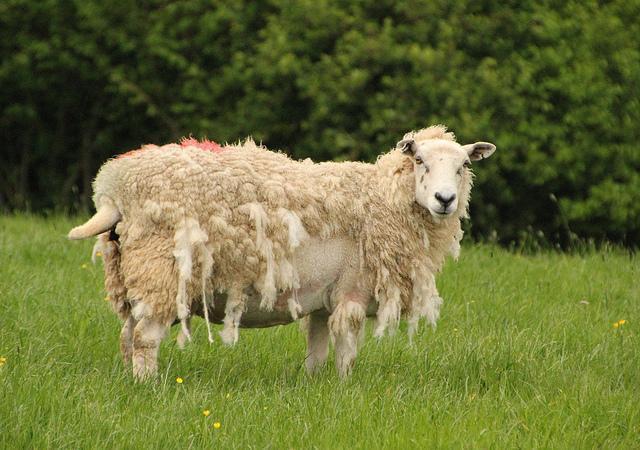How many animals are present?
Give a very brief answer. 1. How many sheep are there?
Give a very brief answer. 1. How many people are touching the ball in this picture?
Give a very brief answer. 0. 